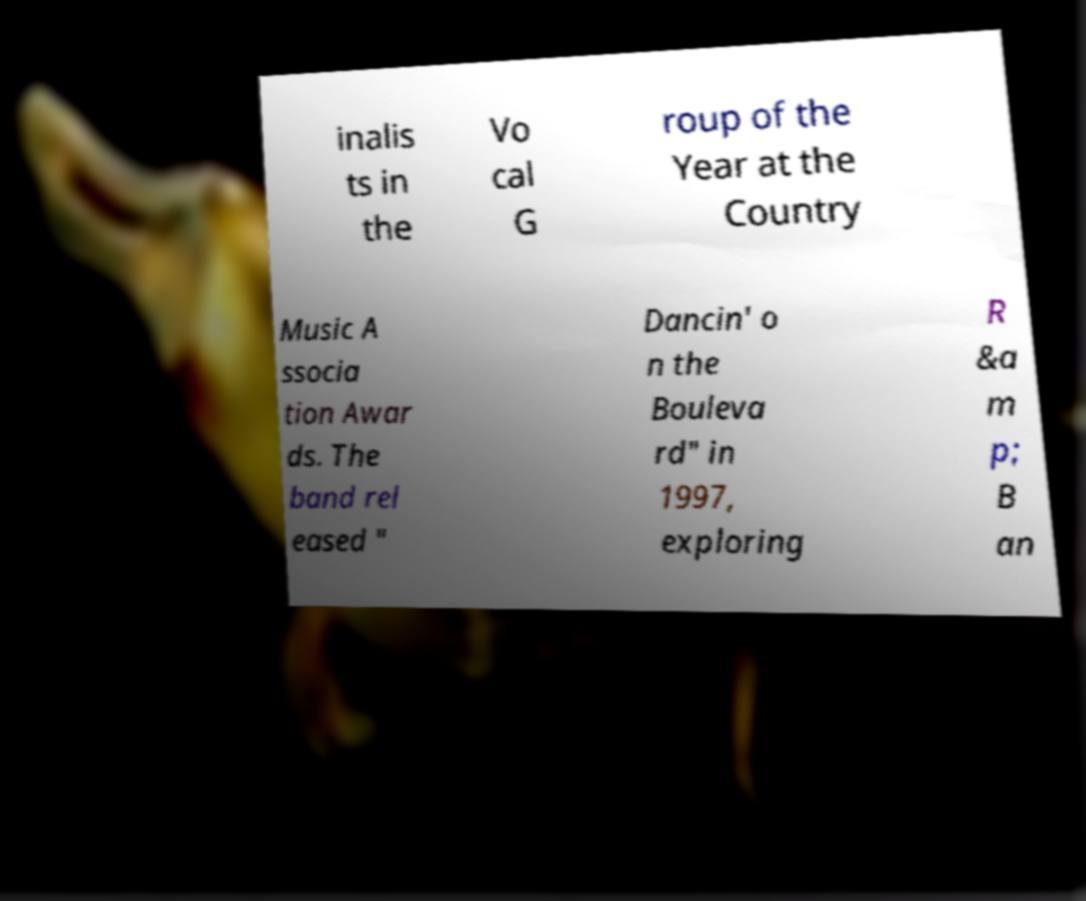There's text embedded in this image that I need extracted. Can you transcribe it verbatim? inalis ts in the Vo cal G roup of the Year at the Country Music A ssocia tion Awar ds. The band rel eased " Dancin' o n the Bouleva rd" in 1997, exploring R &a m p; B an 